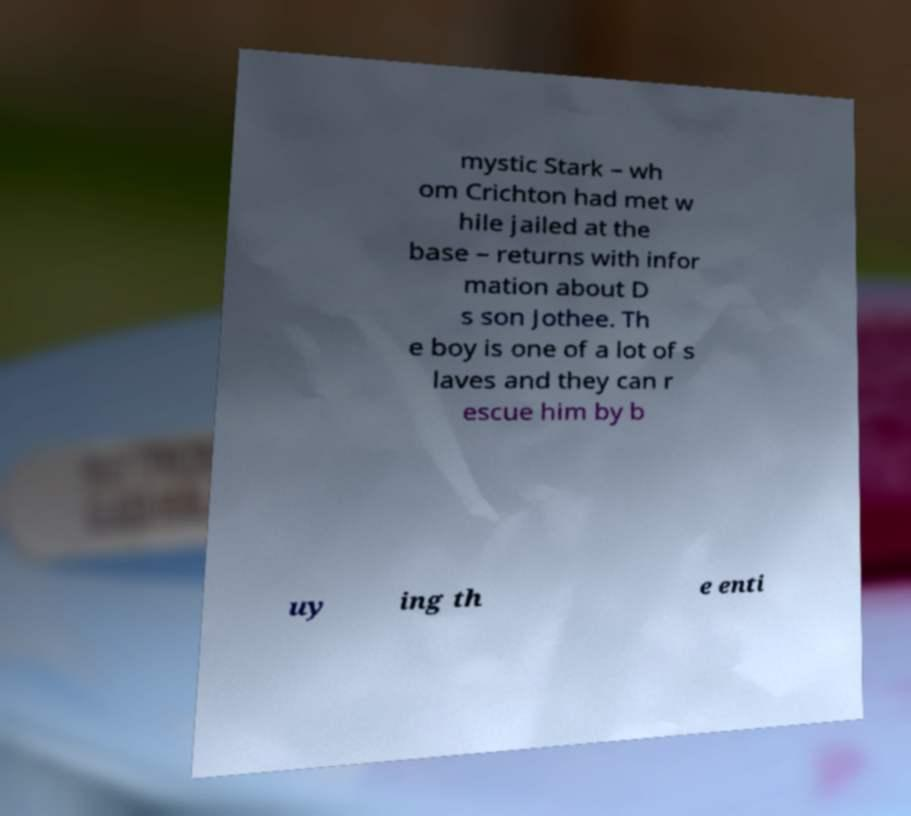Can you accurately transcribe the text from the provided image for me? mystic Stark – wh om Crichton had met w hile jailed at the base – returns with infor mation about D s son Jothee. Th e boy is one of a lot of s laves and they can r escue him by b uy ing th e enti 